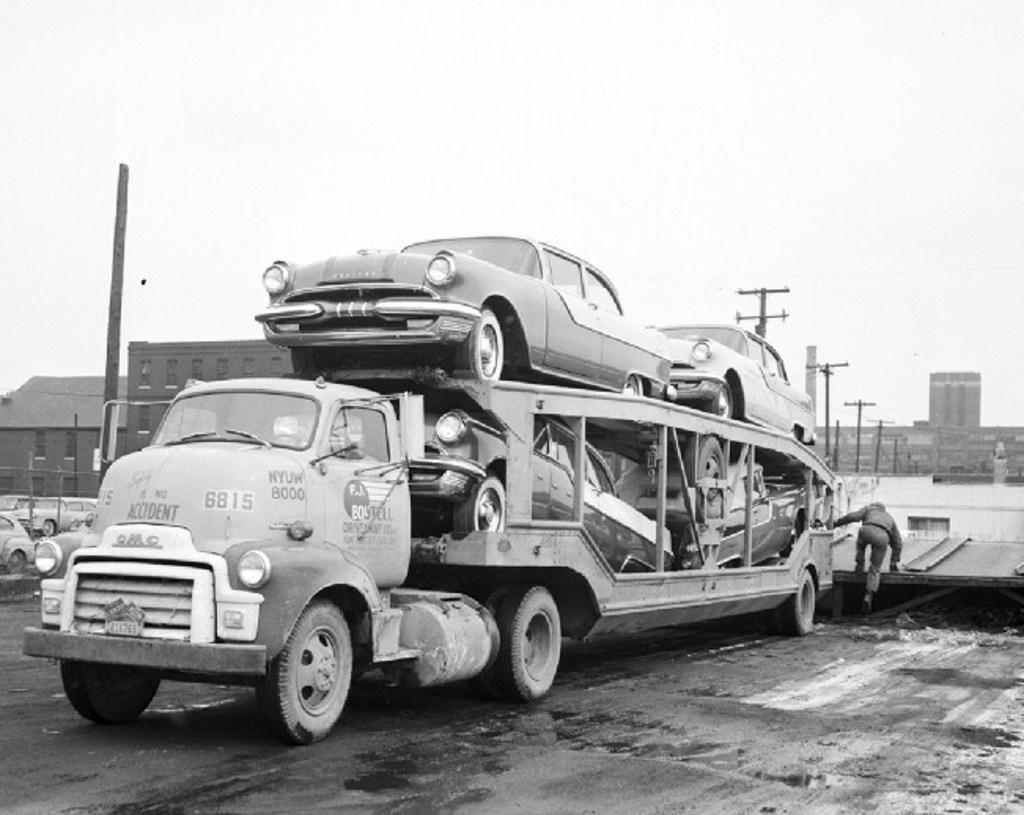How would you summarize this image in a sentence or two? In this picture I can see vehicles, there is a person, there are buildings, there are poles, and in the background there is the sky. 